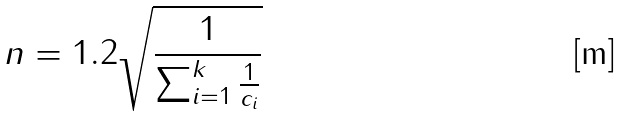Convert formula to latex. <formula><loc_0><loc_0><loc_500><loc_500>n = 1 . 2 \sqrt { \frac { 1 } { \sum _ { i = 1 } ^ { k } \frac { 1 } { c _ { i } } } }</formula> 